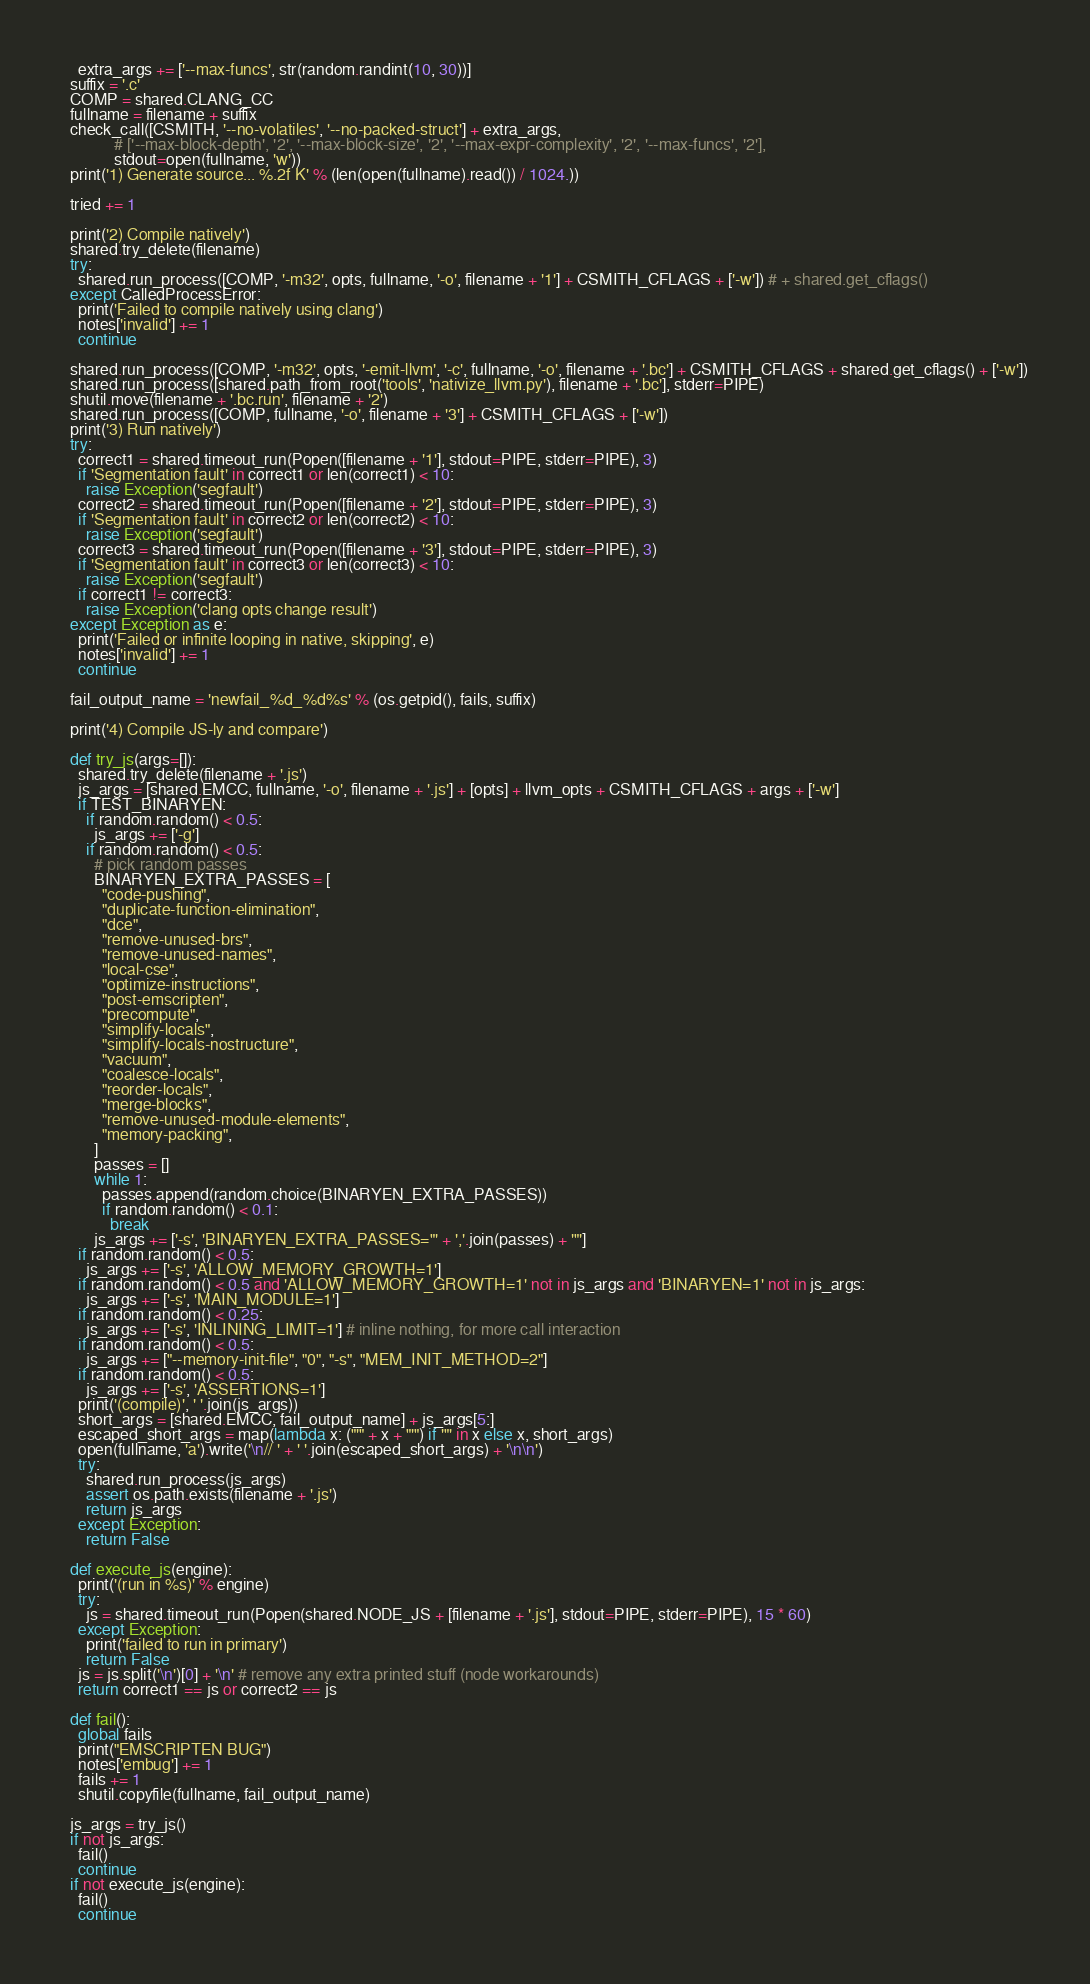Convert code to text. <code><loc_0><loc_0><loc_500><loc_500><_Python_>    extra_args += ['--max-funcs', str(random.randint(10, 30))]
  suffix = '.c'
  COMP = shared.CLANG_CC
  fullname = filename + suffix
  check_call([CSMITH, '--no-volatiles', '--no-packed-struct'] + extra_args,
             # ['--max-block-depth', '2', '--max-block-size', '2', '--max-expr-complexity', '2', '--max-funcs', '2'],
             stdout=open(fullname, 'w'))
  print('1) Generate source... %.2f K' % (len(open(fullname).read()) / 1024.))

  tried += 1

  print('2) Compile natively')
  shared.try_delete(filename)
  try:
    shared.run_process([COMP, '-m32', opts, fullname, '-o', filename + '1'] + CSMITH_CFLAGS + ['-w']) # + shared.get_cflags()
  except CalledProcessError:
    print('Failed to compile natively using clang')
    notes['invalid'] += 1
    continue

  shared.run_process([COMP, '-m32', opts, '-emit-llvm', '-c', fullname, '-o', filename + '.bc'] + CSMITH_CFLAGS + shared.get_cflags() + ['-w'])
  shared.run_process([shared.path_from_root('tools', 'nativize_llvm.py'), filename + '.bc'], stderr=PIPE)
  shutil.move(filename + '.bc.run', filename + '2')
  shared.run_process([COMP, fullname, '-o', filename + '3'] + CSMITH_CFLAGS + ['-w'])
  print('3) Run natively')
  try:
    correct1 = shared.timeout_run(Popen([filename + '1'], stdout=PIPE, stderr=PIPE), 3)
    if 'Segmentation fault' in correct1 or len(correct1) < 10:
      raise Exception('segfault')
    correct2 = shared.timeout_run(Popen([filename + '2'], stdout=PIPE, stderr=PIPE), 3)
    if 'Segmentation fault' in correct2 or len(correct2) < 10:
      raise Exception('segfault')
    correct3 = shared.timeout_run(Popen([filename + '3'], stdout=PIPE, stderr=PIPE), 3)
    if 'Segmentation fault' in correct3 or len(correct3) < 10:
      raise Exception('segfault')
    if correct1 != correct3:
      raise Exception('clang opts change result')
  except Exception as e:
    print('Failed or infinite looping in native, skipping', e)
    notes['invalid'] += 1
    continue

  fail_output_name = 'newfail_%d_%d%s' % (os.getpid(), fails, suffix)

  print('4) Compile JS-ly and compare')

  def try_js(args=[]):
    shared.try_delete(filename + '.js')
    js_args = [shared.EMCC, fullname, '-o', filename + '.js'] + [opts] + llvm_opts + CSMITH_CFLAGS + args + ['-w']
    if TEST_BINARYEN:
      if random.random() < 0.5:
        js_args += ['-g']
      if random.random() < 0.5:
        # pick random passes
        BINARYEN_EXTRA_PASSES = [
          "code-pushing",
          "duplicate-function-elimination",
          "dce",
          "remove-unused-brs",
          "remove-unused-names",
          "local-cse",
          "optimize-instructions",
          "post-emscripten",
          "precompute",
          "simplify-locals",
          "simplify-locals-nostructure",
          "vacuum",
          "coalesce-locals",
          "reorder-locals",
          "merge-blocks",
          "remove-unused-module-elements",
          "memory-packing",
        ]
        passes = []
        while 1:
          passes.append(random.choice(BINARYEN_EXTRA_PASSES))
          if random.random() < 0.1:
            break
        js_args += ['-s', 'BINARYEN_EXTRA_PASSES="' + ','.join(passes) + '"']
    if random.random() < 0.5:
      js_args += ['-s', 'ALLOW_MEMORY_GROWTH=1']
    if random.random() < 0.5 and 'ALLOW_MEMORY_GROWTH=1' not in js_args and 'BINARYEN=1' not in js_args:
      js_args += ['-s', 'MAIN_MODULE=1']
    if random.random() < 0.25:
      js_args += ['-s', 'INLINING_LIMIT=1'] # inline nothing, for more call interaction
    if random.random() < 0.5:
      js_args += ["--memory-init-file", "0", "-s", "MEM_INIT_METHOD=2"]
    if random.random() < 0.5:
      js_args += ['-s', 'ASSERTIONS=1']
    print('(compile)', ' '.join(js_args))
    short_args = [shared.EMCC, fail_output_name] + js_args[5:]
    escaped_short_args = map(lambda x: ("'" + x + "'") if '"' in x else x, short_args)
    open(fullname, 'a').write('\n// ' + ' '.join(escaped_short_args) + '\n\n')
    try:
      shared.run_process(js_args)
      assert os.path.exists(filename + '.js')
      return js_args
    except Exception:
      return False

  def execute_js(engine):
    print('(run in %s)' % engine)
    try:
      js = shared.timeout_run(Popen(shared.NODE_JS + [filename + '.js'], stdout=PIPE, stderr=PIPE), 15 * 60)
    except Exception:
      print('failed to run in primary')
      return False
    js = js.split('\n')[0] + '\n' # remove any extra printed stuff (node workarounds)
    return correct1 == js or correct2 == js

  def fail():
    global fails
    print("EMSCRIPTEN BUG")
    notes['embug'] += 1
    fails += 1
    shutil.copyfile(fullname, fail_output_name)

  js_args = try_js()
  if not js_args:
    fail()
    continue
  if not execute_js(engine):
    fail()
    continue
</code> 